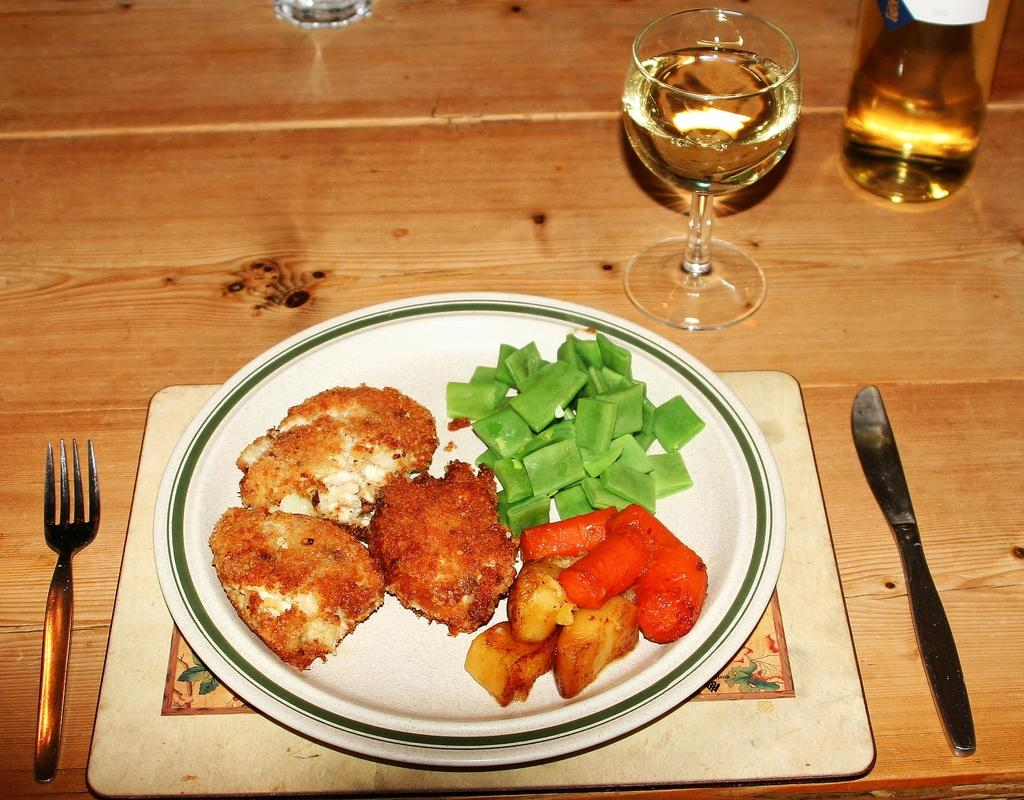What is the color of the plate in the image? The plate in the image is white. What is on the plate? Food items are present on the plate. What utensils can be seen in the image? There is a fork and a spoon in the image. What is the glass used for in the image? The glass is likely used for holding a beverage. What is the surface that the plate and utensils are placed on? The wooden surface suggests it might be a table or countertop. What type of crime is being committed in the image? There is no crime present in the image; it features a plate with food items, utensils, and a glass on a wooden surface. What kind of carriage is visible in the image? There is no carriage present in the image. 